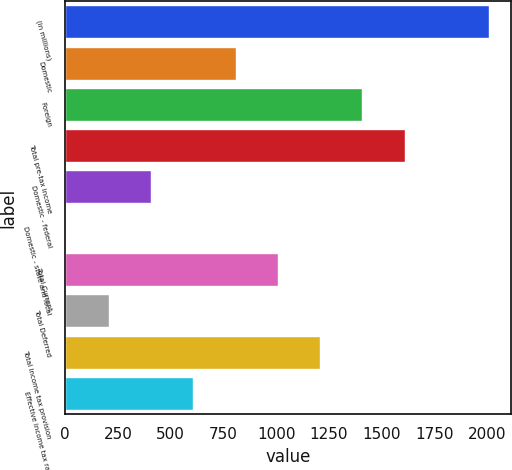Convert chart. <chart><loc_0><loc_0><loc_500><loc_500><bar_chart><fcel>(in millions)<fcel>Domestic<fcel>Foreign<fcel>Total pre-tax income<fcel>Domestic - federal<fcel>Domestic - state and local<fcel>Total Current<fcel>Total Deferred<fcel>Total income tax provision<fcel>Effective income tax rate<nl><fcel>2011<fcel>807.4<fcel>1409.2<fcel>1609.8<fcel>406.2<fcel>5<fcel>1008<fcel>205.6<fcel>1208.6<fcel>606.8<nl></chart> 